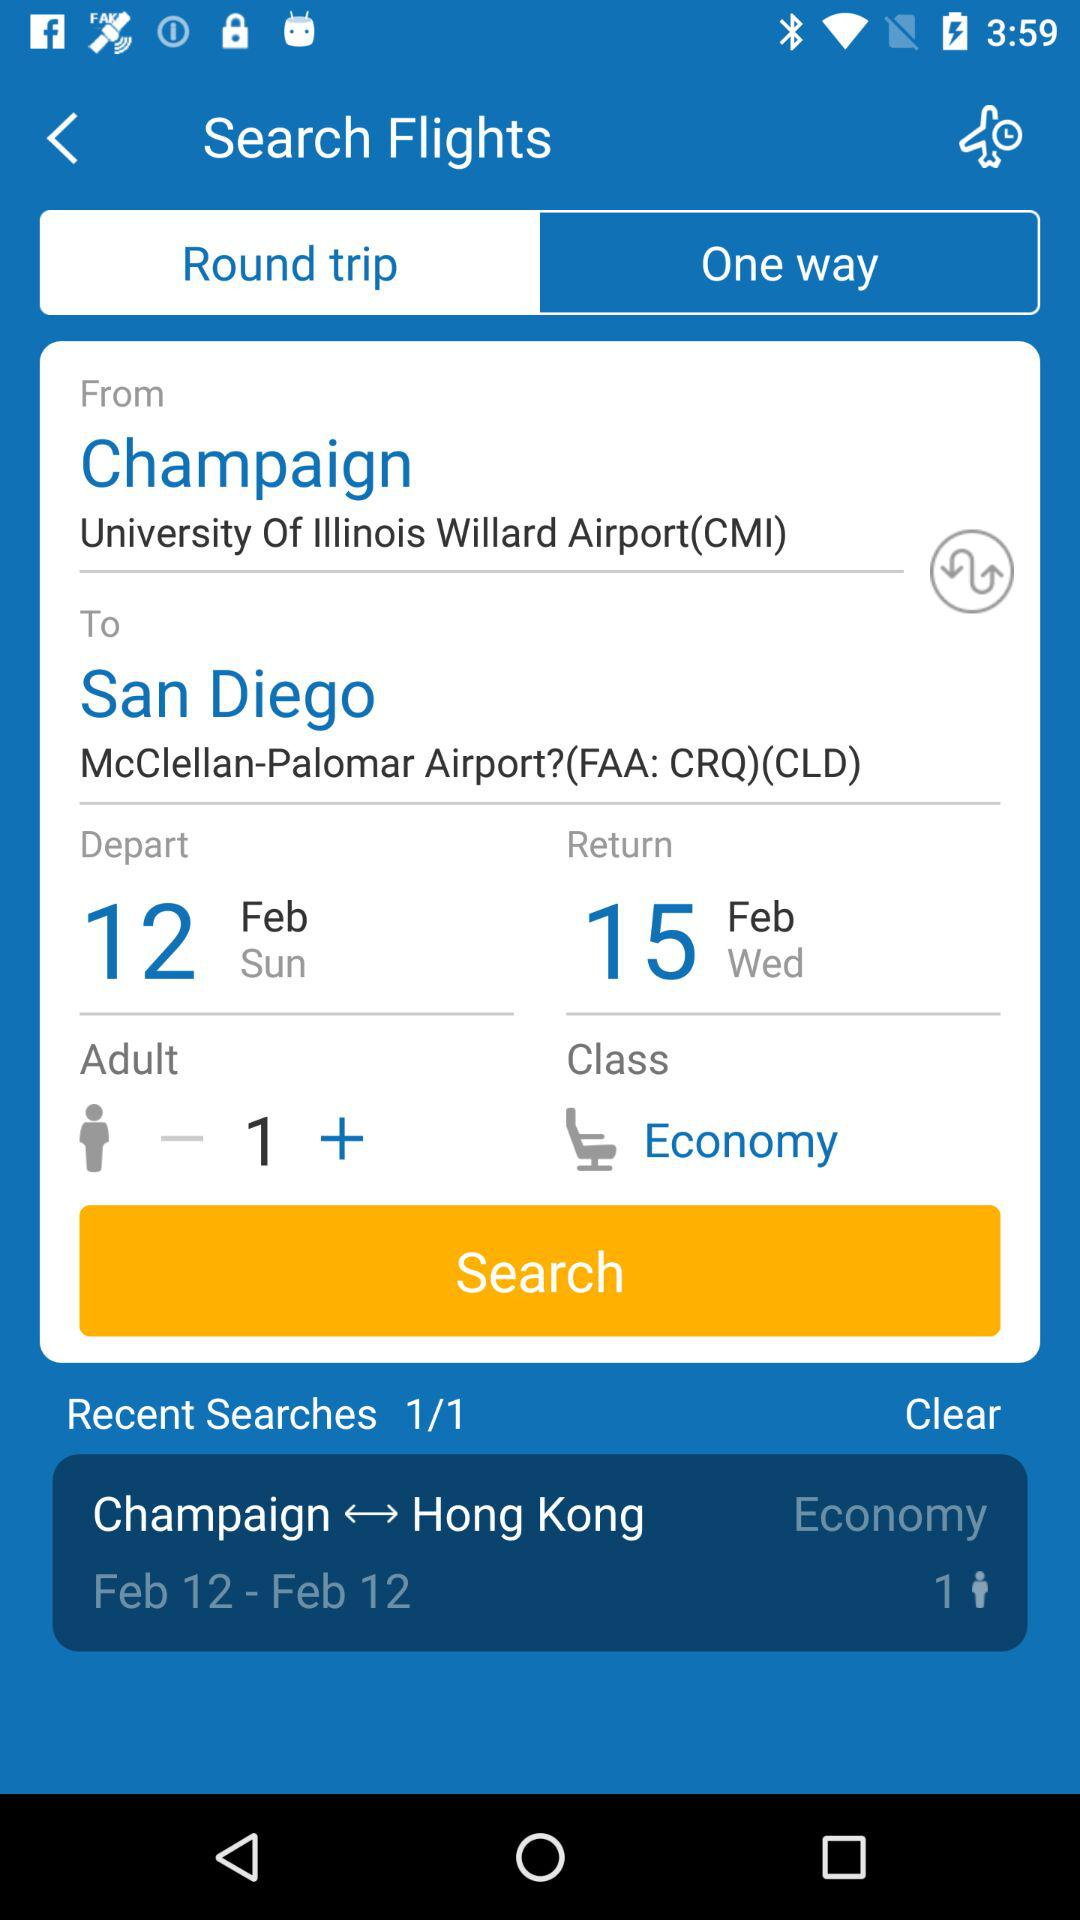How many people are flying?
Answer the question using a single word or phrase. 1 